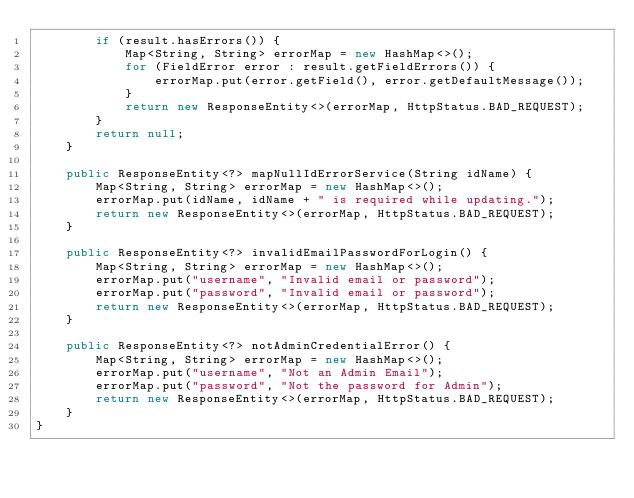Convert code to text. <code><loc_0><loc_0><loc_500><loc_500><_Java_>        if (result.hasErrors()) {
            Map<String, String> errorMap = new HashMap<>();
            for (FieldError error : result.getFieldErrors()) {
                errorMap.put(error.getField(), error.getDefaultMessage());
            }
            return new ResponseEntity<>(errorMap, HttpStatus.BAD_REQUEST);
        }
        return null;
    }

    public ResponseEntity<?> mapNullIdErrorService(String idName) {
        Map<String, String> errorMap = new HashMap<>();
        errorMap.put(idName, idName + " is required while updating.");
        return new ResponseEntity<>(errorMap, HttpStatus.BAD_REQUEST);
    }

    public ResponseEntity<?> invalidEmailPasswordForLogin() {
        Map<String, String> errorMap = new HashMap<>();
        errorMap.put("username", "Invalid email or password");
        errorMap.put("password", "Invalid email or password");
        return new ResponseEntity<>(errorMap, HttpStatus.BAD_REQUEST);
    }

    public ResponseEntity<?> notAdminCredentialError() {
        Map<String, String> errorMap = new HashMap<>();
        errorMap.put("username", "Not an Admin Email");
        errorMap.put("password", "Not the password for Admin");
        return new ResponseEntity<>(errorMap, HttpStatus.BAD_REQUEST);
    }
}
</code> 